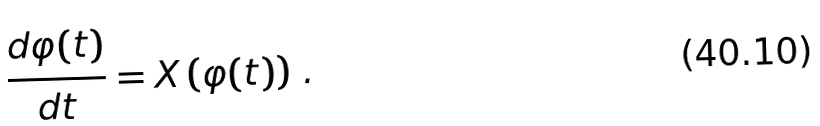<formula> <loc_0><loc_0><loc_500><loc_500>\frac { d \varphi ( t ) } { d t } = X \left ( \varphi ( t ) \right ) \, .</formula> 